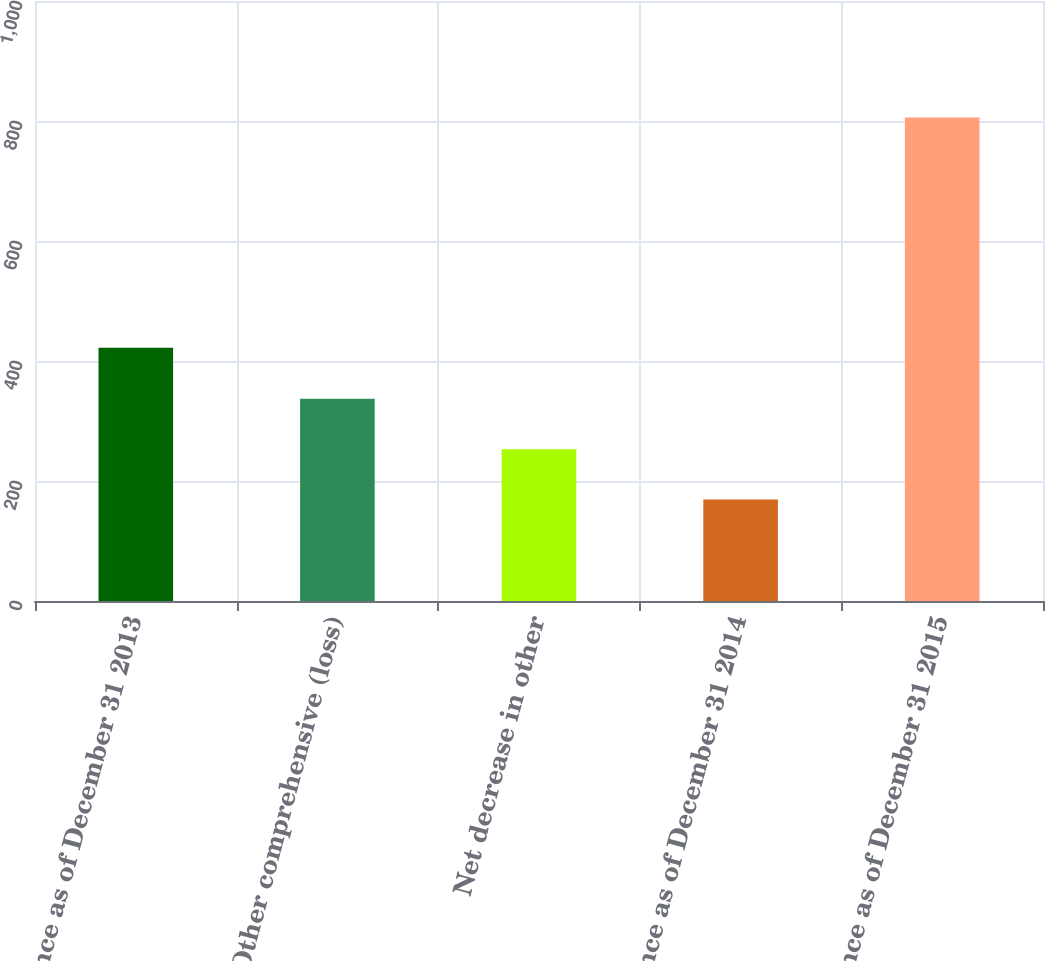<chart> <loc_0><loc_0><loc_500><loc_500><bar_chart><fcel>Balance as of December 31 2013<fcel>Other comprehensive (loss)<fcel>Net decrease in other<fcel>Balance as of December 31 2014<fcel>Balance as of December 31 2015<nl><fcel>422<fcel>337<fcel>253<fcel>169<fcel>806<nl></chart> 